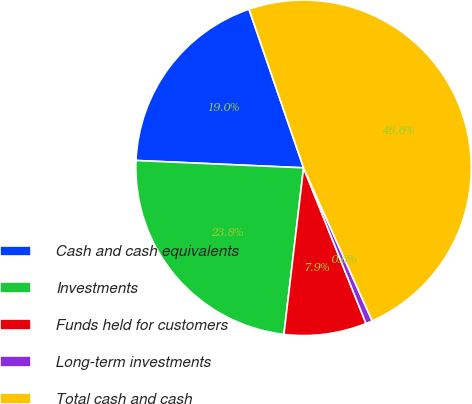Convert chart to OTSL. <chart><loc_0><loc_0><loc_500><loc_500><pie_chart><fcel>Cash and cash equivalents<fcel>Investments<fcel>Funds held for customers<fcel>Long-term investments<fcel>Total cash and cash<nl><fcel>19.03%<fcel>23.83%<fcel>7.94%<fcel>0.64%<fcel>48.57%<nl></chart> 